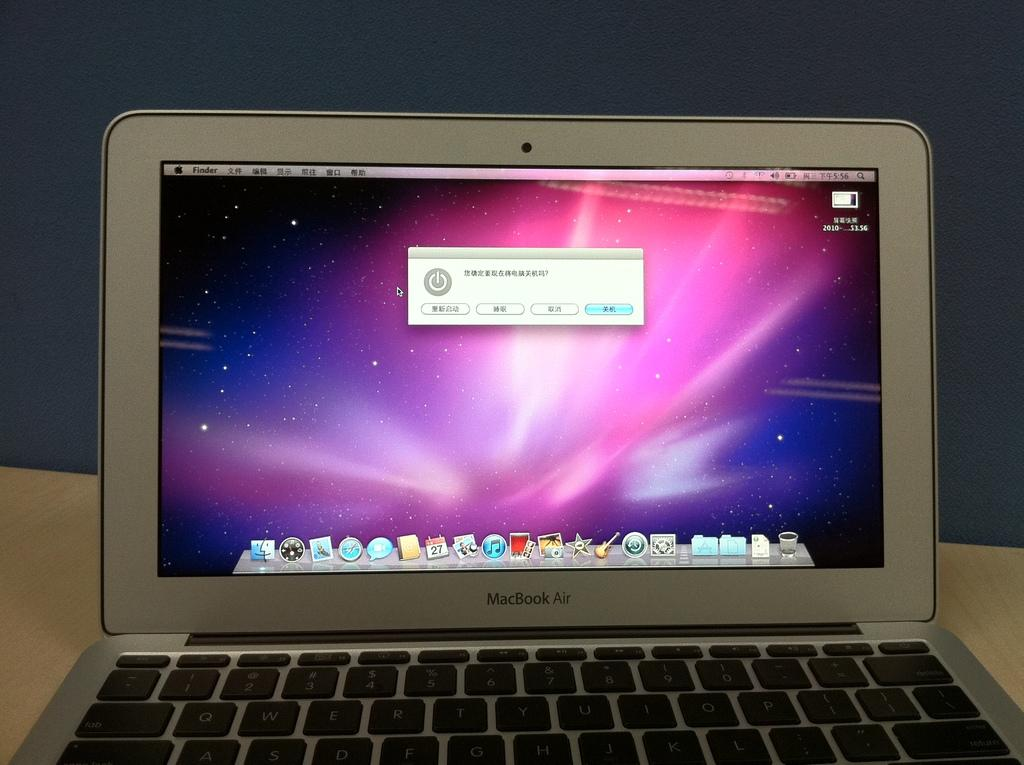<image>
Offer a succinct explanation of the picture presented. MacBook Air is the brand shown on this open laptop. 